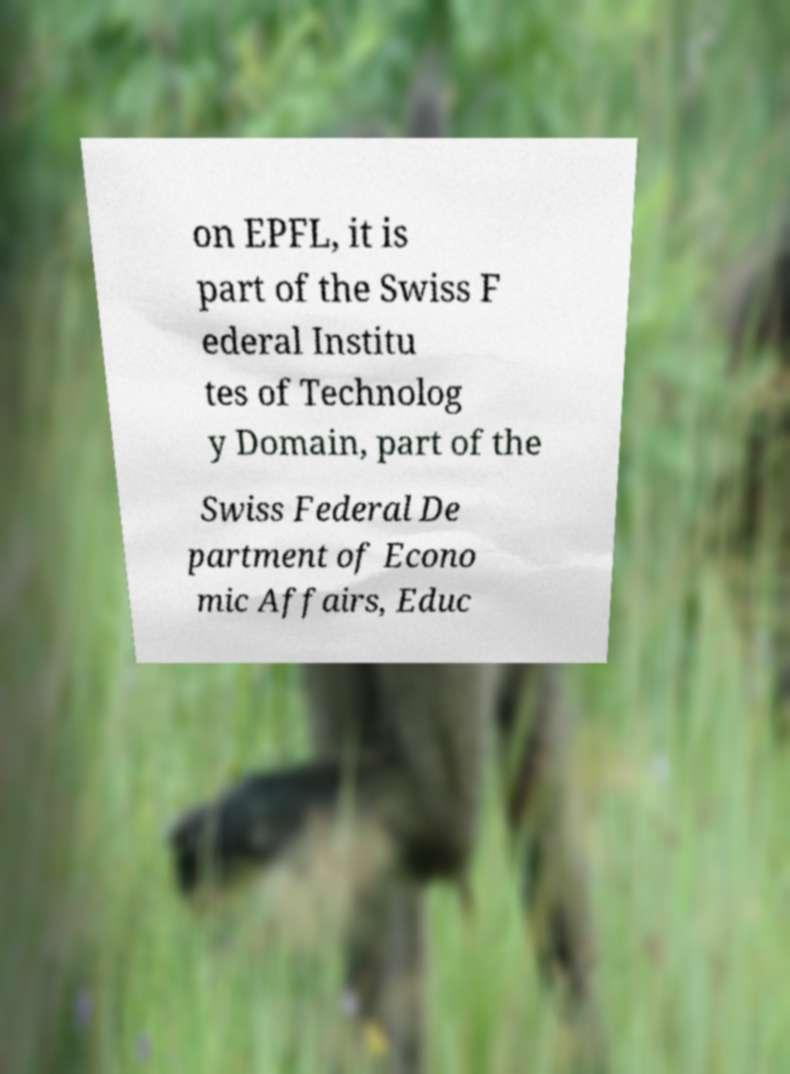Please read and relay the text visible in this image. What does it say? on EPFL, it is part of the Swiss F ederal Institu tes of Technolog y Domain, part of the Swiss Federal De partment of Econo mic Affairs, Educ 